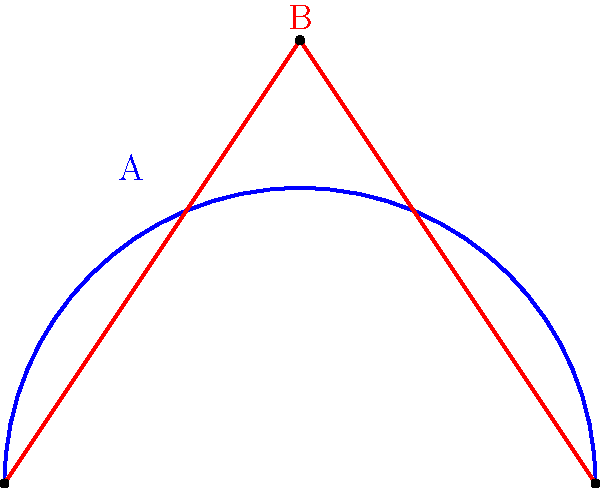In your research on cycling aerodynamics for Andy Hampsten's biography, you come across two helmet designs: a semicircular shape (A) and a triangular shape (B). Both helmets have the same base width of 4 units. If the triangular helmet has a height of 3 units, what is the ratio of the surface area of helmet A to helmet B? Let's approach this step-by-step:

1) For helmet A (semicircle):
   - Radius = 2 units (half of the base width)
   - Surface area = $\frac{1}{2} \cdot \pi r^2 = \frac{1}{2} \cdot \pi \cdot 2^2 = 2\pi$ square units

2) For helmet B (triangle):
   - Base = 4 units
   - Height = 3 units
   - Surface area = $\frac{1}{2} \cdot base \cdot height = \frac{1}{2} \cdot 4 \cdot 3 = 6$ square units

3) Ratio of surface area of A to B:
   $\frac{Area_A}{Area_B} = \frac{2\pi}{6} = \frac{\pi}{3}$

4) This can be simplified to approximately 1.047 : 1

The ratio $\frac{\pi}{3}$ represents the relative surface areas, which could impact the aerodynamic properties of the helmets.
Answer: $\frac{\pi}{3}$ : 1 